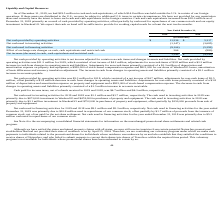From Travelzoo's financial document, What is the net cash provided by operating activities in 2019 and 2018 respectively? The document shows two values: $11,236 and $5,317 (in thousands). From the document: "cash provided by operating activities $ 11,236 $ 5,317 Net cash provided by operating activities $ 11,236 $ 5,317..." Also, What is the net cash used in investing activities in 2019 and 2018 respectively? The document shows two values: 1,147 and 3,685 (in thousands). From the document: "Net cash used in investing activities (1,147) (3,685) Net cash used in investing activities (1,147) (3,685)..." Also, What is the net cash used in financing activities in 2019 and 2018 respectively? The document shows two values: 9,106 and 5,292 (in thousands). From the document: "Net cash used in financing activities (9,106) (5,292) Net cash used in financing activities (9,106) (5,292)..." Also, can you calculate: What is the change in net cash provided by operating activities between 2019 and 2018? Based on the calculation: 11,236-5,317, the result is 5919 (in thousands). This is based on the information: "Net cash provided by operating activities $ 11,236 $ 5,317 cash provided by operating activities $ 11,236 $ 5,317..." The key data points involved are: 11,236, 5,317. Also, can you calculate: What is the change in cash paid for income taxes, net of refunds received between 2019 and 2018? Based on the calculation: 4.7-4.3, the result is 0.4 (in millions). This is based on the information: "ion for 2018, which consisted of a net income of $4.7 million, adjustments for non-cash items of $2.5 received in 2019 and 2018, was $4.7 million and $4.3 million, respectively...." The key data points involved are: 4.3, 4.7. Additionally, Which year has a higher net cash provided by operating activities? According to the financial document, 2019. The relevant text states: "2019 2018..." 